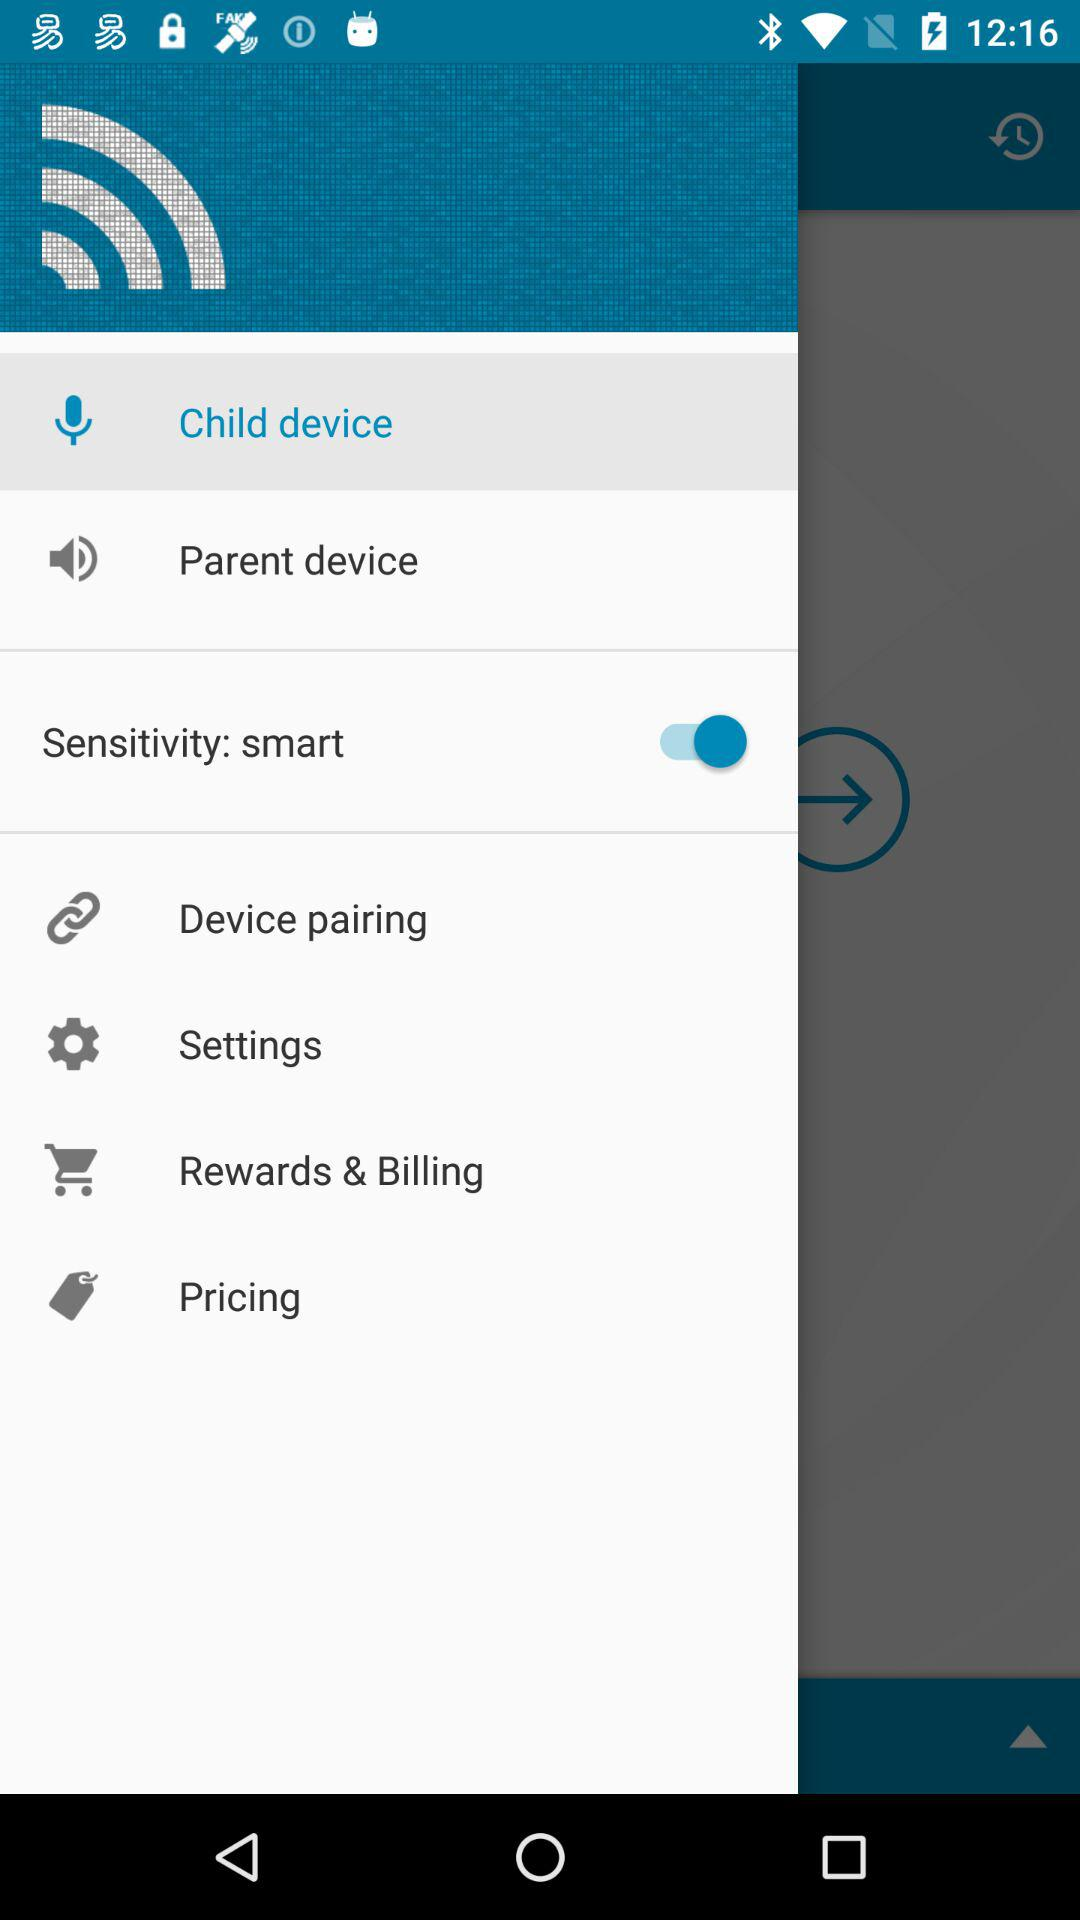What is the status of sensitivity? The status of sensitivity is on. 